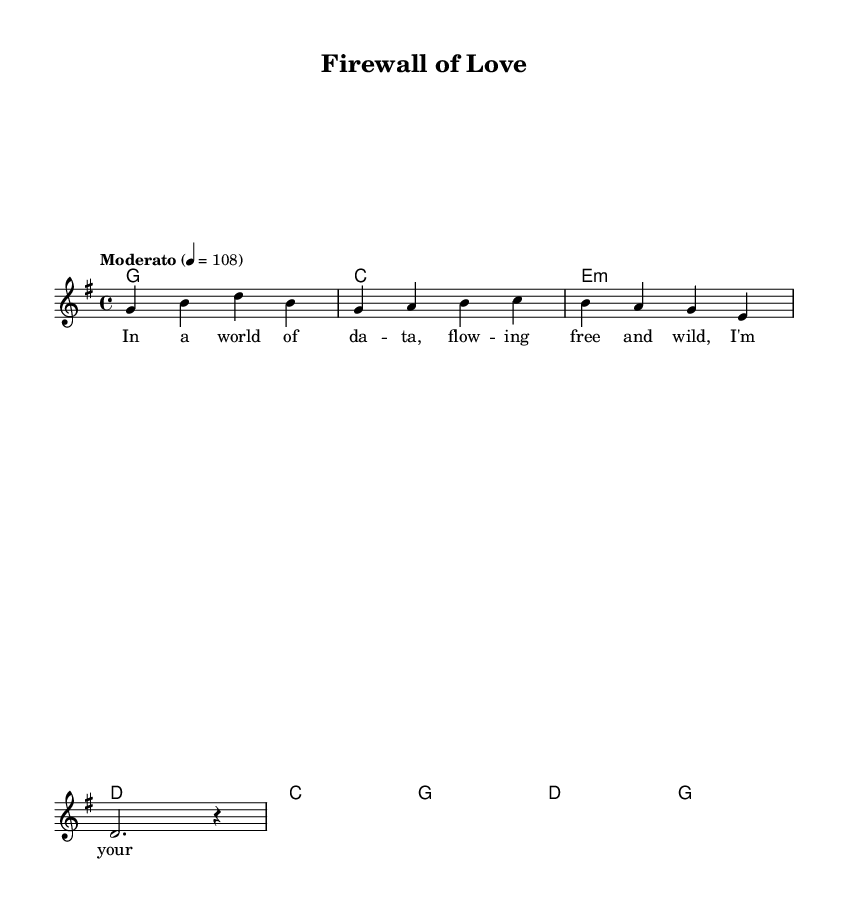What is the key signature of this music? The key signature indicates that the piece is in G major, which has one sharp (F#). This can be concluded by looking at the key signature at the beginning of the score, where the F# is noted, confirming it is G major.
Answer: G major What is the time signature of this music? The time signature is determined by the two numbers at the beginning of the score. Here, it reads 4/4, which means there are four beats in each measure, and the quarter note gets one beat. This is a common time signature used in many musical genres, including country rock.
Answer: 4/4 What is the tempo marking of this music? The tempo marking is indicated in the score with a descriptive word that suggests the speed at which the music is to be played. In this sheet music, it states "Moderato," which indicates a moderate pace, specifically at 108 beats per minute.
Answer: Moderato What is the first chord of the verse? The first chord is found in the verse section of the music. The chord above the first measure in the chord mode typically indicates the chord played, which in this case is G. This assessment is made by recognizing the chord's position relative to the junction of music and lyrics.
Answer: G Identify the main theme of the lyrics based on the title. The title "Firewall of Love" suggests a protective theme regarding personal information, aligning with the lyrics that convey a sense of guarding and safeguarding data. This can be analyzed by connecting the title and the opening lines that discuss being a guardian to the data.
Answer: Protection What is the structure of the song? By observing the events in the score, the song follows a typical verse-chorus structure. The verse is presented first, followed by the chorus, indicating a repetition pattern which is commonly used in country rock to engage the listener. This is derived from the arrangement of the song sections in the score.
Answer: Verse-Chorus How many measures are in the chorus? The total number of measures can be counted within the chorus section, which consists of four measures in this instance. This assessment is made visually by counting each measure's chord representation in the chorus section of the sheet music.
Answer: 4 